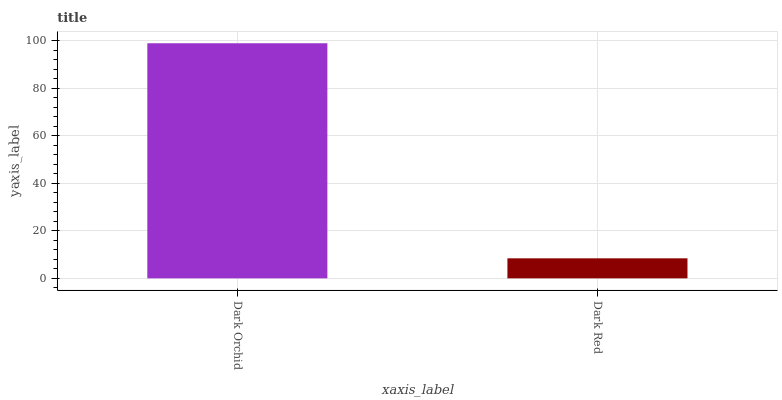Is Dark Red the minimum?
Answer yes or no. Yes. Is Dark Orchid the maximum?
Answer yes or no. Yes. Is Dark Red the maximum?
Answer yes or no. No. Is Dark Orchid greater than Dark Red?
Answer yes or no. Yes. Is Dark Red less than Dark Orchid?
Answer yes or no. Yes. Is Dark Red greater than Dark Orchid?
Answer yes or no. No. Is Dark Orchid less than Dark Red?
Answer yes or no. No. Is Dark Orchid the high median?
Answer yes or no. Yes. Is Dark Red the low median?
Answer yes or no. Yes. Is Dark Red the high median?
Answer yes or no. No. Is Dark Orchid the low median?
Answer yes or no. No. 